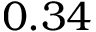<formula> <loc_0><loc_0><loc_500><loc_500>0 . 3 4</formula> 